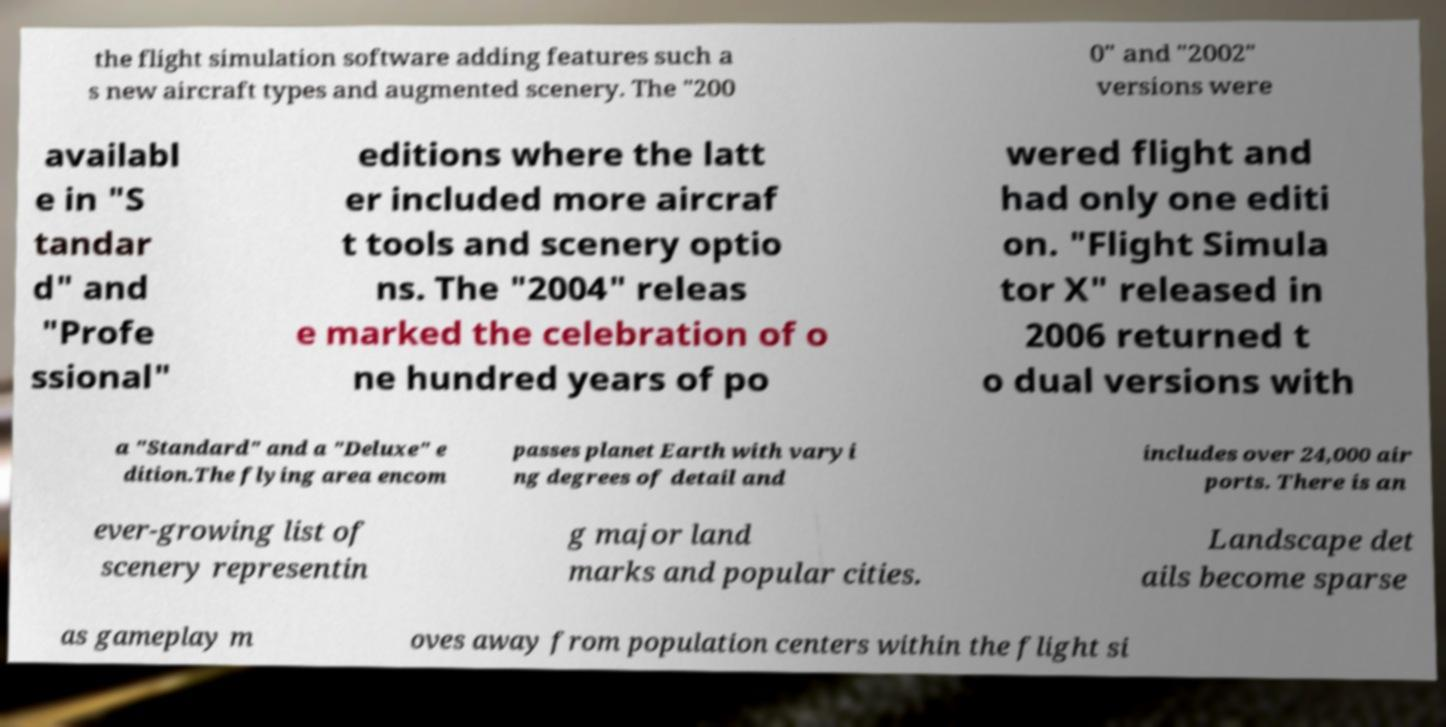There's text embedded in this image that I need extracted. Can you transcribe it verbatim? the flight simulation software adding features such a s new aircraft types and augmented scenery. The "200 0" and "2002" versions were availabl e in "S tandar d" and "Profe ssional" editions where the latt er included more aircraf t tools and scenery optio ns. The "2004" releas e marked the celebration of o ne hundred years of po wered flight and had only one editi on. "Flight Simula tor X" released in 2006 returned t o dual versions with a "Standard" and a "Deluxe" e dition.The flying area encom passes planet Earth with varyi ng degrees of detail and includes over 24,000 air ports. There is an ever-growing list of scenery representin g major land marks and popular cities. Landscape det ails become sparse as gameplay m oves away from population centers within the flight si 